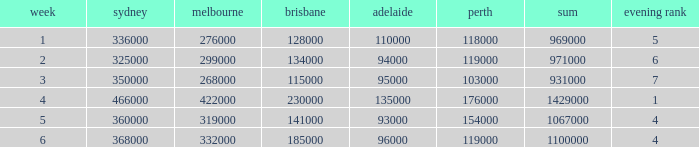What was the rating for Brisbane the week that Adelaide had 94000? 134000.0. 